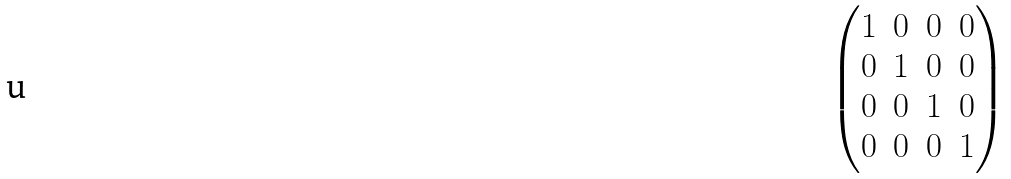<formula> <loc_0><loc_0><loc_500><loc_500>\begin{pmatrix} 1 & 0 & 0 & 0 \\ 0 & 1 & 0 & 0 \\ 0 & 0 & 1 & 0 \\ 0 & 0 & 0 & 1 \\ \end{pmatrix}</formula> 